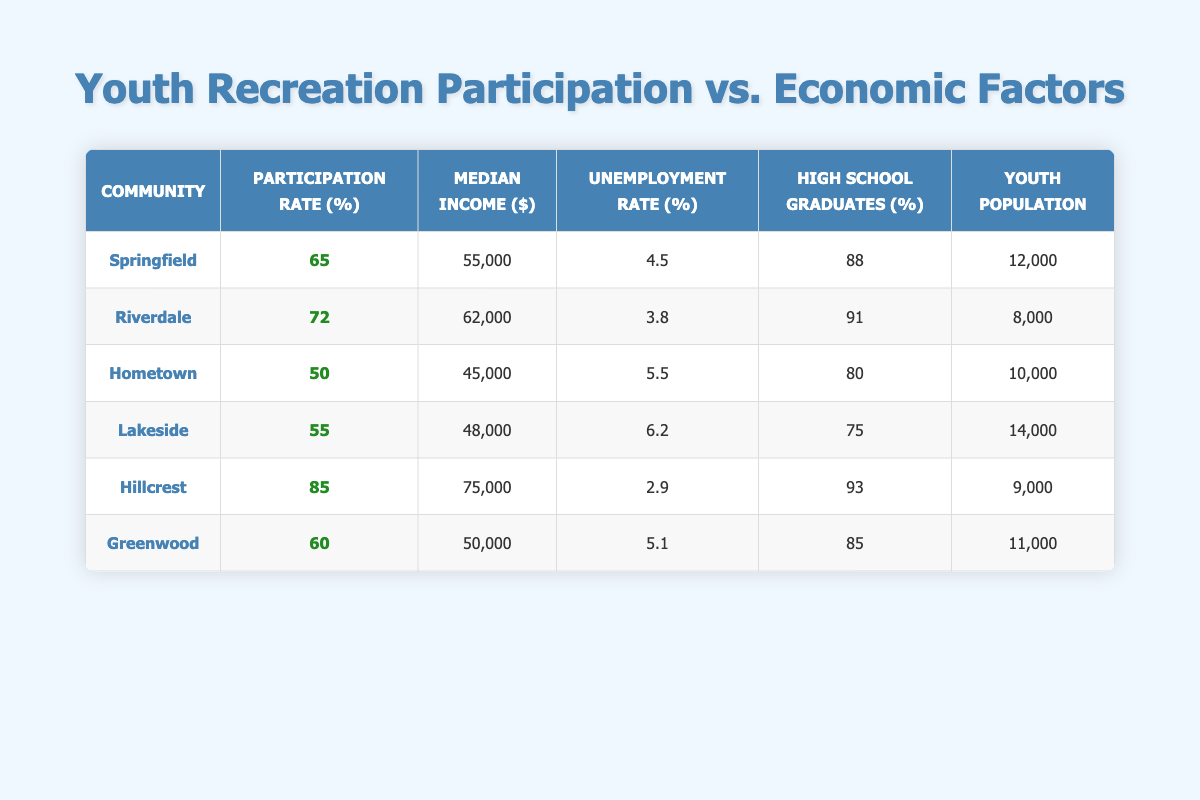What is the participation rate of Hillcrest? Referring to the table, Hillcrest has a participation rate listed in the second column, which shows 85%.
Answer: 85 Which community has the highest median income? Looking at the median income column, the highest value is 75000, associated with Hillcrest.
Answer: Hillcrest Is the unemployment rate in Riverdale lower than that in Springfield? By comparing the unemployment rates, Riverdale has 3.8 while Springfield has 4.5, so yes, Riverdale's rate is lower.
Answer: Yes What is the average participation rate of the communities listed? To find the average, sum all participation rates (65 + 72 + 50 + 55 + 85 + 60) = 387. Then, divide by the number of communities, which is 6; hence, the average participation rate = 387 / 6 = 64.5.
Answer: 64.5 Which community has both a high school graduation rate above 90% and a participation rate above 80%? Examining the table, Hillcrest is the only community meeting both conditions: it has a high school graduation rate of 93% and a participation rate of 85%.
Answer: Hillcrest Does Lakeside have a lower participation rate compared to Greenwood? Lakeside's participation rate is 55% while Greenwood's is 60%, so Lakeside does indeed have a lower rate.
Answer: Yes What is the difference in youth population between Hometown and Hillcrest? The youth population for Hometown is 10000 and for Hillcrest it is 9000. The difference is calculated as 10000 - 9000 = 1000.
Answer: 1000 How many communities have a median income above 50000? By checking the median income for each community, Riverdale (62000), Hillcrest (75000), and Greenwood (50000) meet the criteria, equating to 3 communities above 50000.
Answer: 3 If we were to rank the communities by participation rate, which community would be fourth? The sorted participation rates in descending order are Hillcrest (85), Riverdale (72), Springfield (65), and Greenwood (60). Thus, Greenwood ranks fourth.
Answer: Greenwood 